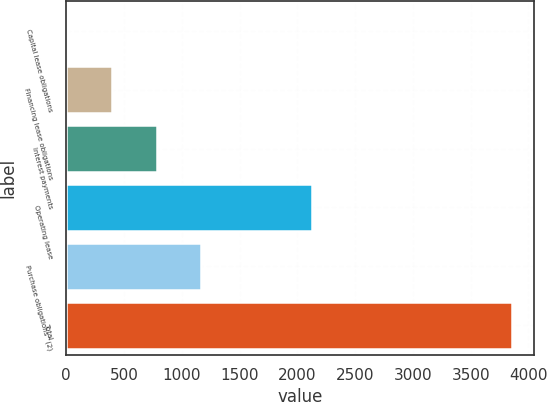Convert chart. <chart><loc_0><loc_0><loc_500><loc_500><bar_chart><fcel>Capital lease obligations<fcel>Financing lease obligations<fcel>Interest payments<fcel>Operating lease<fcel>Purchase obligations^(2)<fcel>Total<nl><fcel>12<fcel>396.7<fcel>781.4<fcel>2130<fcel>1166.1<fcel>3859<nl></chart> 